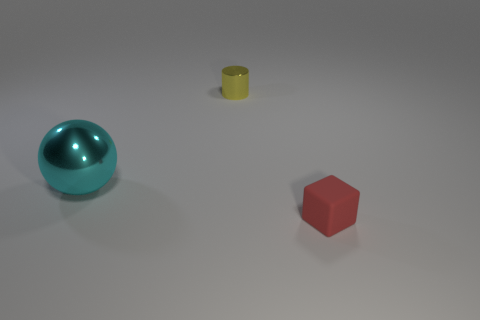Are there any other things that are made of the same material as the red thing?
Offer a very short reply. No. Are there any other things that are the same size as the shiny ball?
Your response must be concise. No. Are there fewer tiny yellow metallic things in front of the cube than spheres that are behind the large object?
Offer a terse response. No. There is a object that is on the right side of the large object and on the left side of the red cube; what shape is it?
Your response must be concise. Cylinder. The yellow cylinder that is the same material as the big sphere is what size?
Your answer should be very brief. Small. There is a big metallic ball; is it the same color as the thing that is to the right of the small yellow cylinder?
Make the answer very short. No. What material is the thing that is to the left of the red block and in front of the tiny metallic cylinder?
Keep it short and to the point. Metal. Does the thing on the left side of the yellow metallic cylinder have the same shape as the tiny object that is left of the red cube?
Make the answer very short. No. Is there a gray thing?
Offer a very short reply. No. What color is the other rubber object that is the same size as the yellow object?
Give a very brief answer. Red. 